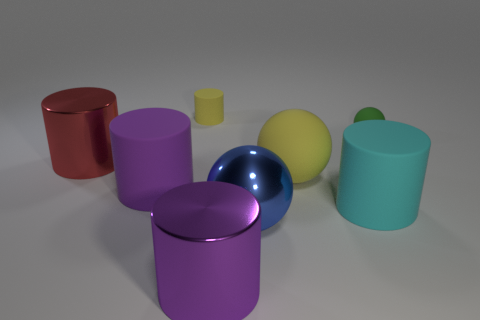Do the big rubber sphere and the tiny rubber cylinder have the same color?
Ensure brevity in your answer.  Yes. What number of things are green objects or big blue cubes?
Keep it short and to the point. 1. There is a yellow thing in front of the tiny green rubber ball; does it have the same size as the yellow object behind the yellow matte ball?
Your response must be concise. No. How many other objects are there of the same material as the big yellow ball?
Your answer should be compact. 4. Are there more big purple objects that are right of the large blue metal ball than purple objects that are in front of the big cyan thing?
Ensure brevity in your answer.  No. What is the material of the purple thing that is behind the big purple metal cylinder?
Offer a terse response. Rubber. Do the red metallic thing and the small green object have the same shape?
Your answer should be compact. No. Are there any other things of the same color as the metallic ball?
Your response must be concise. No. What is the color of the small matte object that is the same shape as the purple metal object?
Offer a terse response. Yellow. Are there more large objects that are on the right side of the tiny green rubber object than big matte balls?
Make the answer very short. No. 